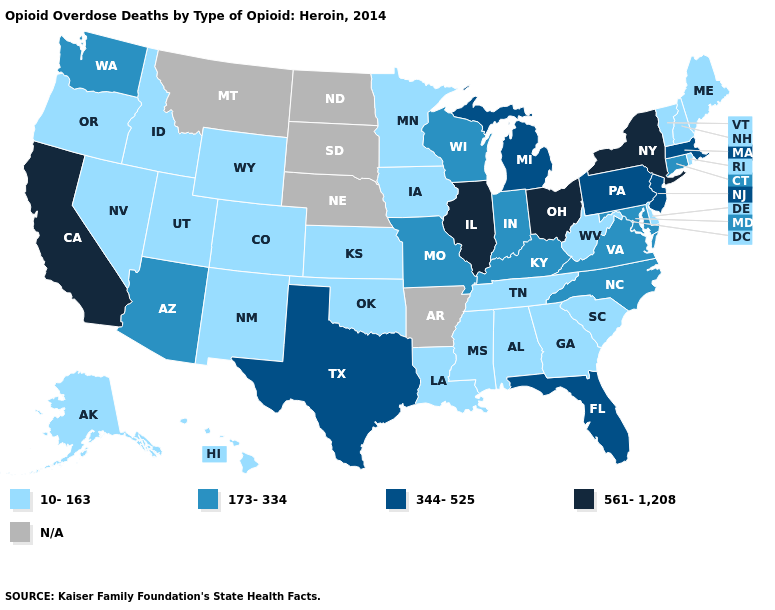What is the highest value in states that border Montana?
Keep it brief. 10-163. Does Illinois have the highest value in the USA?
Concise answer only. Yes. Does New Jersey have the highest value in the Northeast?
Short answer required. No. What is the value of Montana?
Write a very short answer. N/A. Does New York have the highest value in the Northeast?
Be succinct. Yes. What is the value of Arizona?
Quick response, please. 173-334. Name the states that have a value in the range 173-334?
Concise answer only. Arizona, Connecticut, Indiana, Kentucky, Maryland, Missouri, North Carolina, Virginia, Washington, Wisconsin. Does Oklahoma have the lowest value in the South?
Write a very short answer. Yes. Name the states that have a value in the range 344-525?
Concise answer only. Florida, Massachusetts, Michigan, New Jersey, Pennsylvania, Texas. Name the states that have a value in the range 561-1,208?
Be succinct. California, Illinois, New York, Ohio. Name the states that have a value in the range 561-1,208?
Give a very brief answer. California, Illinois, New York, Ohio. Which states have the lowest value in the USA?
Keep it brief. Alabama, Alaska, Colorado, Delaware, Georgia, Hawaii, Idaho, Iowa, Kansas, Louisiana, Maine, Minnesota, Mississippi, Nevada, New Hampshire, New Mexico, Oklahoma, Oregon, Rhode Island, South Carolina, Tennessee, Utah, Vermont, West Virginia, Wyoming. 